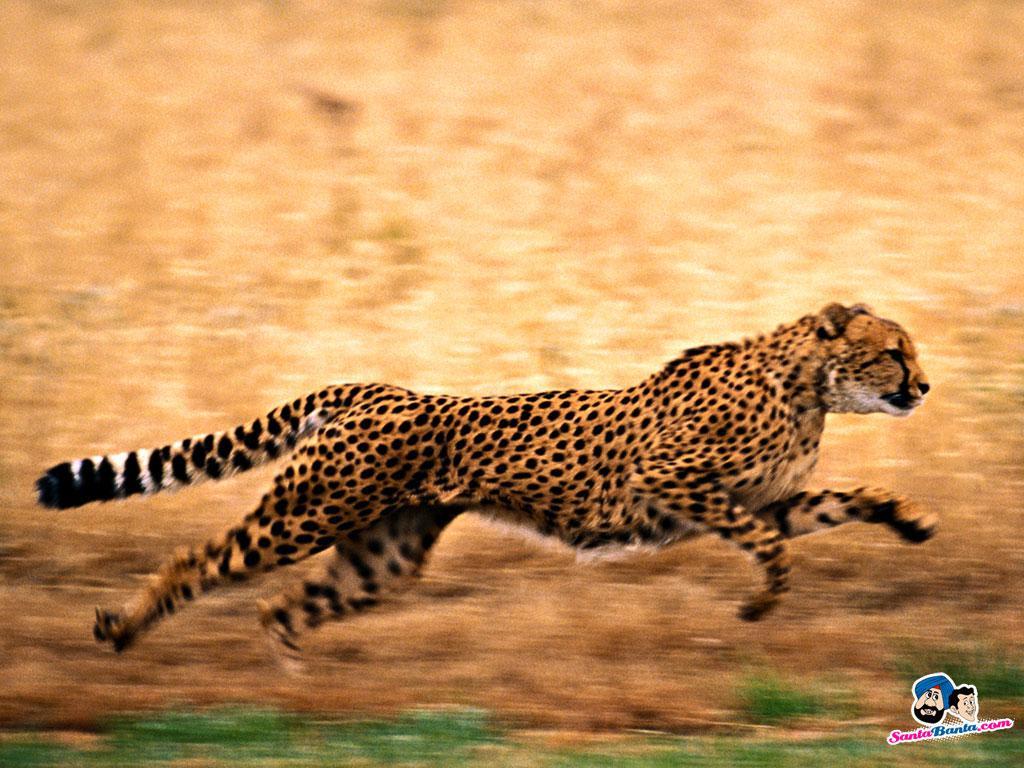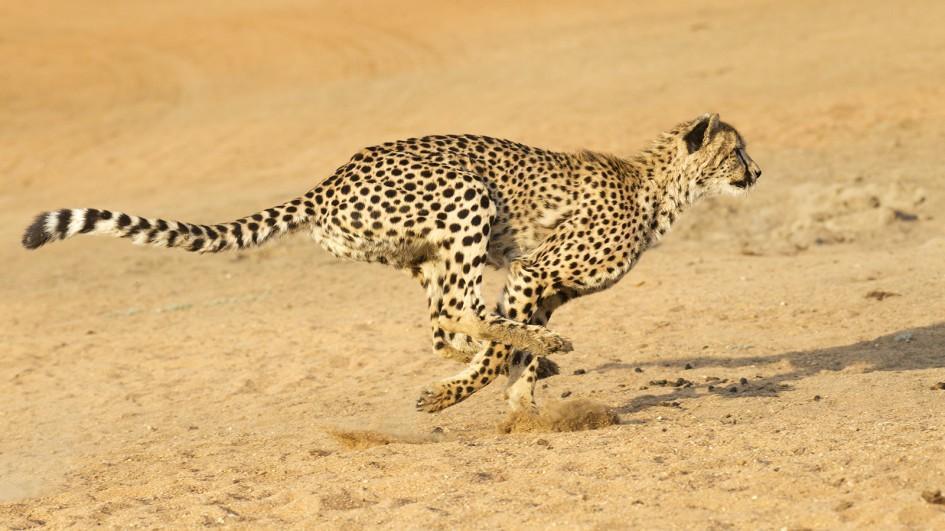The first image is the image on the left, the second image is the image on the right. Considering the images on both sides, is "In one of the images there is a leopard lying on the ground." valid? Answer yes or no. No. 